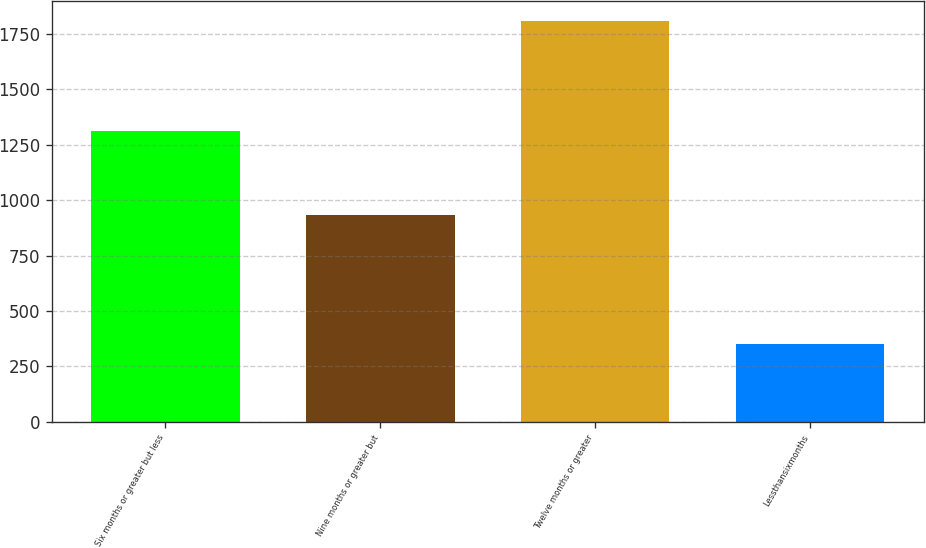Convert chart to OTSL. <chart><loc_0><loc_0><loc_500><loc_500><bar_chart><fcel>Six months or greater but less<fcel>Nine months or greater but<fcel>Twelve months or greater<fcel>Lessthansixmonths<nl><fcel>1314<fcel>934<fcel>1809<fcel>351<nl></chart> 